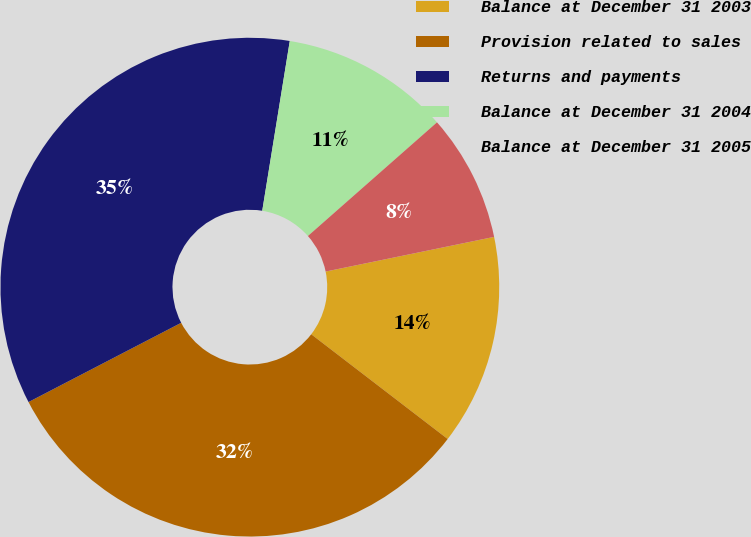Convert chart. <chart><loc_0><loc_0><loc_500><loc_500><pie_chart><fcel>Balance at December 31 2003<fcel>Provision related to sales<fcel>Returns and payments<fcel>Balance at December 31 2004<fcel>Balance at December 31 2005<nl><fcel>13.65%<fcel>31.96%<fcel>35.18%<fcel>10.95%<fcel>8.26%<nl></chart> 